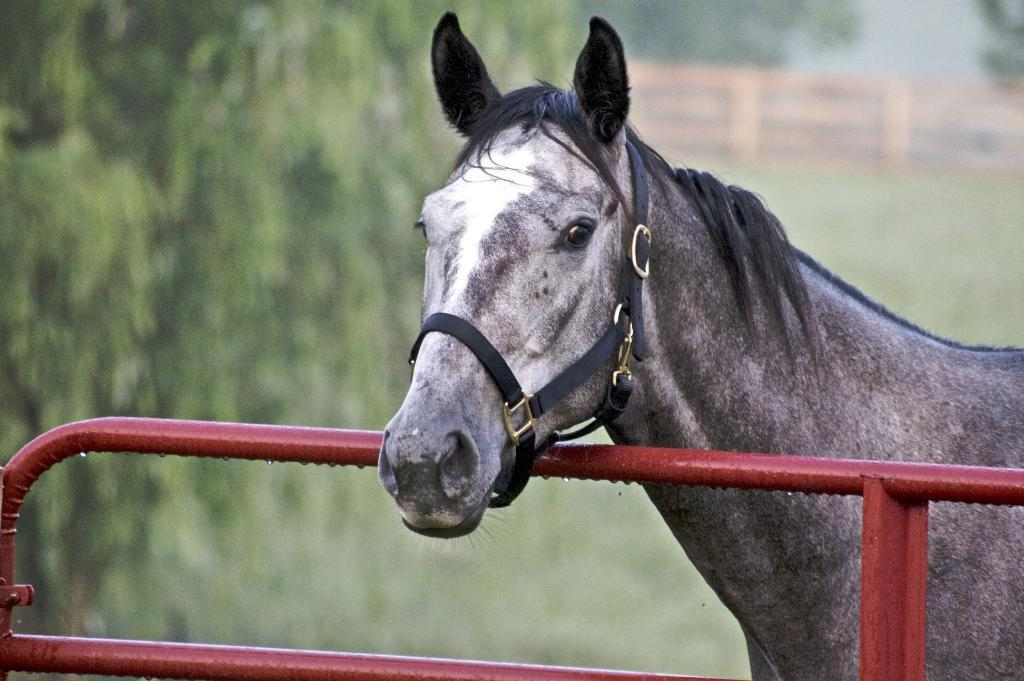What animal can be seen in the image? There is a horse in the image. Where is the horse located in relation to the fence? The horse is behind a fence in the image. What is the location of the fence in the image? The fence is on the right side of the image. What type of terrain is the fence situated on? The fence is on grassland. What can be seen on the left side of the image? There are trees on the left side of the image. What type of beggar can be seen near the horse in the image? There is no beggar present in the image; it only features a horse behind a fence on grassland with trees on the left side. 